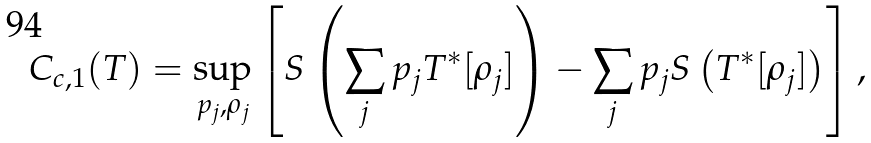<formula> <loc_0><loc_0><loc_500><loc_500>C _ { c , 1 } ( T ) = \sup _ { p _ { j } , \rho _ { j } } \left [ S \left ( \sum _ { j } p _ { j } T ^ { * } [ \rho _ { j } ] \right ) - \sum _ { j } p _ { j } S \left ( T ^ { * } [ \rho _ { j } ] \right ) \right ] ,</formula> 